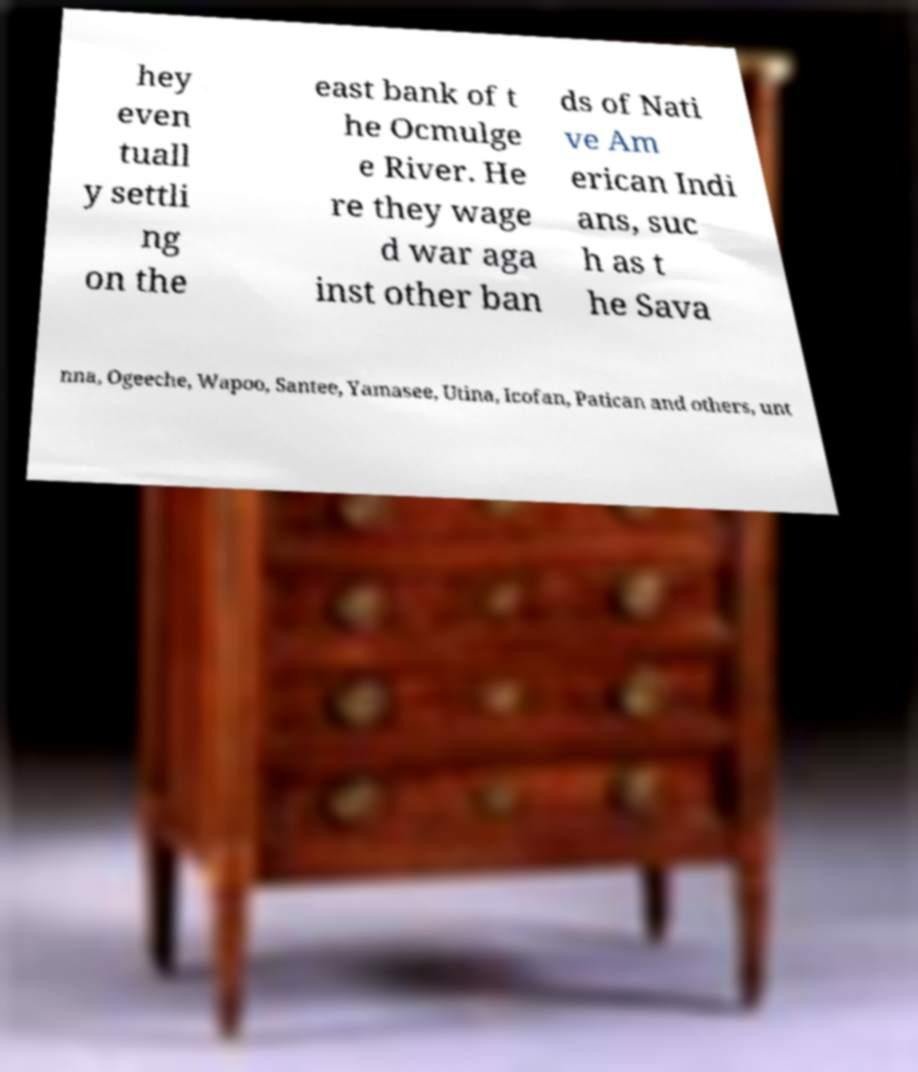I need the written content from this picture converted into text. Can you do that? hey even tuall y settli ng on the east bank of t he Ocmulge e River. He re they wage d war aga inst other ban ds of Nati ve Am erican Indi ans, suc h as t he Sava nna, Ogeeche, Wapoo, Santee, Yamasee, Utina, Icofan, Patican and others, unt 